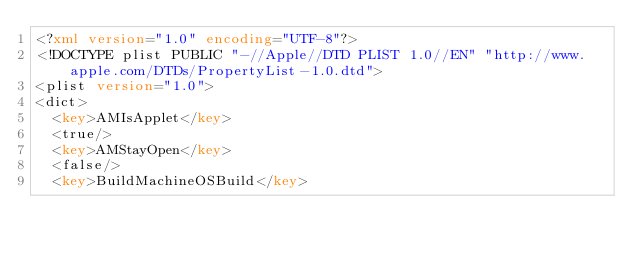<code> <loc_0><loc_0><loc_500><loc_500><_XML_><?xml version="1.0" encoding="UTF-8"?>
<!DOCTYPE plist PUBLIC "-//Apple//DTD PLIST 1.0//EN" "http://www.apple.com/DTDs/PropertyList-1.0.dtd">
<plist version="1.0">
<dict>
	<key>AMIsApplet</key>
	<true/>
	<key>AMStayOpen</key>
	<false/>
	<key>BuildMachineOSBuild</key></code> 